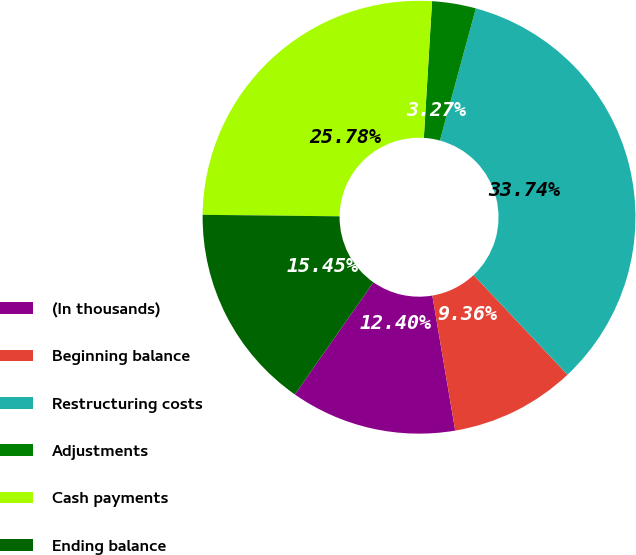Convert chart to OTSL. <chart><loc_0><loc_0><loc_500><loc_500><pie_chart><fcel>(In thousands)<fcel>Beginning balance<fcel>Restructuring costs<fcel>Adjustments<fcel>Cash payments<fcel>Ending balance<nl><fcel>12.4%<fcel>9.36%<fcel>33.74%<fcel>3.27%<fcel>25.78%<fcel>15.45%<nl></chart> 